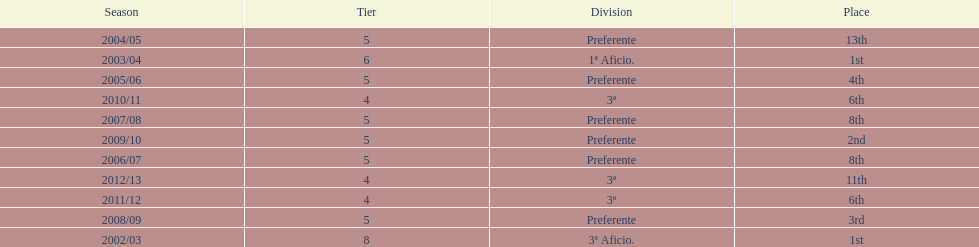How many times did internacional de madrid cf wrap up the season at the peak of their division? 2. 